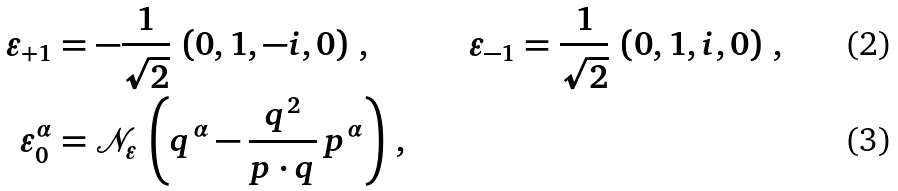<formula> <loc_0><loc_0><loc_500><loc_500>\varepsilon _ { + 1 } & = - \frac { 1 } { \sqrt { 2 } } \, \left ( 0 , 1 , - i , 0 \right ) \, , & \varepsilon _ { - 1 } & = \frac { 1 } { \sqrt { 2 } } \, \left ( 0 , 1 , i , 0 \right ) \, , \\ \varepsilon ^ { \alpha } _ { 0 } & = \mathcal { N } _ { \varepsilon } \, \left ( q ^ { \alpha } - \frac { q ^ { 2 } } { p \cdot q } \, p ^ { \alpha } \right ) \, ,</formula> 